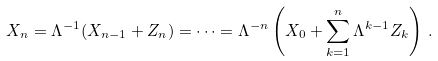Convert formula to latex. <formula><loc_0><loc_0><loc_500><loc_500>X _ { n } = \Lambda ^ { - 1 } ( X _ { n - 1 } + Z _ { n } ) = \dots = \Lambda ^ { - n } \left ( X _ { 0 } + \sum _ { k = 1 } ^ { n } \Lambda ^ { k - 1 } Z _ { k } \right ) \, .</formula> 